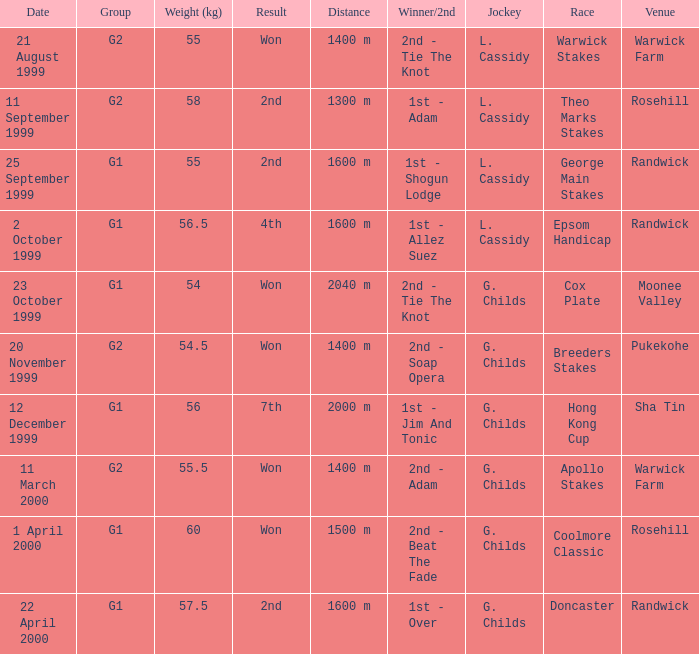List the weight for 56 kilograms. 2000 m. 